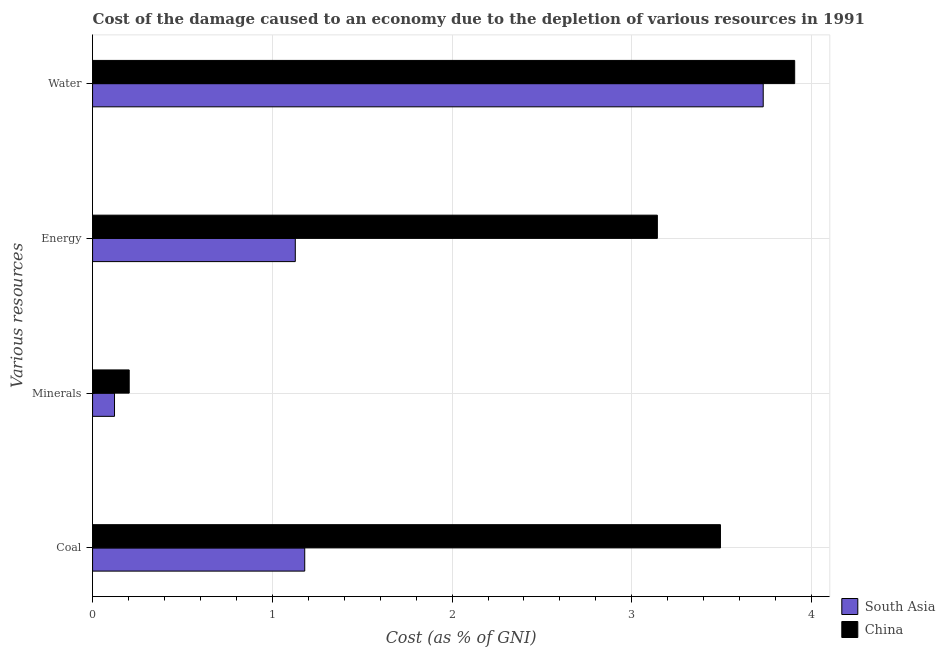How many groups of bars are there?
Ensure brevity in your answer.  4. How many bars are there on the 1st tick from the top?
Offer a very short reply. 2. How many bars are there on the 2nd tick from the bottom?
Your answer should be compact. 2. What is the label of the 2nd group of bars from the top?
Ensure brevity in your answer.  Energy. What is the cost of damage due to depletion of minerals in South Asia?
Your answer should be compact. 0.12. Across all countries, what is the maximum cost of damage due to depletion of minerals?
Give a very brief answer. 0.2. Across all countries, what is the minimum cost of damage due to depletion of water?
Your answer should be compact. 3.73. In which country was the cost of damage due to depletion of energy minimum?
Your response must be concise. South Asia. What is the total cost of damage due to depletion of coal in the graph?
Your answer should be compact. 4.67. What is the difference between the cost of damage due to depletion of coal in China and that in South Asia?
Offer a terse response. 2.31. What is the difference between the cost of damage due to depletion of energy in China and the cost of damage due to depletion of minerals in South Asia?
Make the answer very short. 3.02. What is the average cost of damage due to depletion of coal per country?
Offer a very short reply. 2.34. What is the difference between the cost of damage due to depletion of coal and cost of damage due to depletion of energy in South Asia?
Give a very brief answer. 0.05. What is the ratio of the cost of damage due to depletion of water in South Asia to that in China?
Provide a succinct answer. 0.96. Is the difference between the cost of damage due to depletion of water in South Asia and China greater than the difference between the cost of damage due to depletion of energy in South Asia and China?
Give a very brief answer. Yes. What is the difference between the highest and the second highest cost of damage due to depletion of energy?
Your answer should be very brief. 2.01. What is the difference between the highest and the lowest cost of damage due to depletion of energy?
Keep it short and to the point. 2.01. Is the sum of the cost of damage due to depletion of minerals in South Asia and China greater than the maximum cost of damage due to depletion of energy across all countries?
Your response must be concise. No. What does the 1st bar from the bottom in Coal represents?
Provide a succinct answer. South Asia. Is it the case that in every country, the sum of the cost of damage due to depletion of coal and cost of damage due to depletion of minerals is greater than the cost of damage due to depletion of energy?
Your answer should be very brief. Yes. Are all the bars in the graph horizontal?
Your response must be concise. Yes. What is the difference between two consecutive major ticks on the X-axis?
Provide a short and direct response. 1. Does the graph contain grids?
Your response must be concise. Yes. Where does the legend appear in the graph?
Offer a terse response. Bottom right. What is the title of the graph?
Keep it short and to the point. Cost of the damage caused to an economy due to the depletion of various resources in 1991 . What is the label or title of the X-axis?
Offer a very short reply. Cost (as % of GNI). What is the label or title of the Y-axis?
Your response must be concise. Various resources. What is the Cost (as % of GNI) in South Asia in Coal?
Keep it short and to the point. 1.18. What is the Cost (as % of GNI) in China in Coal?
Give a very brief answer. 3.49. What is the Cost (as % of GNI) in South Asia in Minerals?
Provide a succinct answer. 0.12. What is the Cost (as % of GNI) in China in Minerals?
Provide a succinct answer. 0.2. What is the Cost (as % of GNI) in South Asia in Energy?
Ensure brevity in your answer.  1.13. What is the Cost (as % of GNI) of China in Energy?
Offer a terse response. 3.14. What is the Cost (as % of GNI) of South Asia in Water?
Keep it short and to the point. 3.73. What is the Cost (as % of GNI) of China in Water?
Your answer should be compact. 3.91. Across all Various resources, what is the maximum Cost (as % of GNI) in South Asia?
Offer a very short reply. 3.73. Across all Various resources, what is the maximum Cost (as % of GNI) of China?
Offer a terse response. 3.91. Across all Various resources, what is the minimum Cost (as % of GNI) in South Asia?
Offer a very short reply. 0.12. Across all Various resources, what is the minimum Cost (as % of GNI) of China?
Keep it short and to the point. 0.2. What is the total Cost (as % of GNI) in South Asia in the graph?
Make the answer very short. 6.16. What is the total Cost (as % of GNI) of China in the graph?
Keep it short and to the point. 10.74. What is the difference between the Cost (as % of GNI) of South Asia in Coal and that in Minerals?
Offer a terse response. 1.06. What is the difference between the Cost (as % of GNI) in China in Coal and that in Minerals?
Make the answer very short. 3.29. What is the difference between the Cost (as % of GNI) of South Asia in Coal and that in Energy?
Offer a very short reply. 0.05. What is the difference between the Cost (as % of GNI) of China in Coal and that in Energy?
Your answer should be very brief. 0.35. What is the difference between the Cost (as % of GNI) of South Asia in Coal and that in Water?
Your answer should be compact. -2.55. What is the difference between the Cost (as % of GNI) of China in Coal and that in Water?
Make the answer very short. -0.41. What is the difference between the Cost (as % of GNI) in South Asia in Minerals and that in Energy?
Your response must be concise. -1.01. What is the difference between the Cost (as % of GNI) of China in Minerals and that in Energy?
Your answer should be very brief. -2.94. What is the difference between the Cost (as % of GNI) of South Asia in Minerals and that in Water?
Ensure brevity in your answer.  -3.61. What is the difference between the Cost (as % of GNI) in China in Minerals and that in Water?
Provide a succinct answer. -3.7. What is the difference between the Cost (as % of GNI) of South Asia in Energy and that in Water?
Your response must be concise. -2.6. What is the difference between the Cost (as % of GNI) of China in Energy and that in Water?
Make the answer very short. -0.76. What is the difference between the Cost (as % of GNI) of South Asia in Coal and the Cost (as % of GNI) of China in Minerals?
Your answer should be very brief. 0.98. What is the difference between the Cost (as % of GNI) in South Asia in Coal and the Cost (as % of GNI) in China in Energy?
Give a very brief answer. -1.96. What is the difference between the Cost (as % of GNI) in South Asia in Coal and the Cost (as % of GNI) in China in Water?
Keep it short and to the point. -2.73. What is the difference between the Cost (as % of GNI) in South Asia in Minerals and the Cost (as % of GNI) in China in Energy?
Provide a succinct answer. -3.02. What is the difference between the Cost (as % of GNI) of South Asia in Minerals and the Cost (as % of GNI) of China in Water?
Your response must be concise. -3.78. What is the difference between the Cost (as % of GNI) of South Asia in Energy and the Cost (as % of GNI) of China in Water?
Give a very brief answer. -2.78. What is the average Cost (as % of GNI) of South Asia per Various resources?
Provide a short and direct response. 1.54. What is the average Cost (as % of GNI) in China per Various resources?
Your answer should be very brief. 2.69. What is the difference between the Cost (as % of GNI) of South Asia and Cost (as % of GNI) of China in Coal?
Provide a short and direct response. -2.31. What is the difference between the Cost (as % of GNI) of South Asia and Cost (as % of GNI) of China in Minerals?
Keep it short and to the point. -0.08. What is the difference between the Cost (as % of GNI) in South Asia and Cost (as % of GNI) in China in Energy?
Offer a terse response. -2.01. What is the difference between the Cost (as % of GNI) of South Asia and Cost (as % of GNI) of China in Water?
Your answer should be compact. -0.18. What is the ratio of the Cost (as % of GNI) in South Asia in Coal to that in Minerals?
Give a very brief answer. 9.67. What is the ratio of the Cost (as % of GNI) of China in Coal to that in Minerals?
Provide a short and direct response. 17.14. What is the ratio of the Cost (as % of GNI) in South Asia in Coal to that in Energy?
Provide a succinct answer. 1.05. What is the ratio of the Cost (as % of GNI) in China in Coal to that in Energy?
Give a very brief answer. 1.11. What is the ratio of the Cost (as % of GNI) of South Asia in Coal to that in Water?
Make the answer very short. 0.32. What is the ratio of the Cost (as % of GNI) in China in Coal to that in Water?
Give a very brief answer. 0.89. What is the ratio of the Cost (as % of GNI) of South Asia in Minerals to that in Energy?
Offer a terse response. 0.11. What is the ratio of the Cost (as % of GNI) in China in Minerals to that in Energy?
Your answer should be very brief. 0.06. What is the ratio of the Cost (as % of GNI) of South Asia in Minerals to that in Water?
Make the answer very short. 0.03. What is the ratio of the Cost (as % of GNI) of China in Minerals to that in Water?
Keep it short and to the point. 0.05. What is the ratio of the Cost (as % of GNI) of South Asia in Energy to that in Water?
Keep it short and to the point. 0.3. What is the ratio of the Cost (as % of GNI) in China in Energy to that in Water?
Make the answer very short. 0.8. What is the difference between the highest and the second highest Cost (as % of GNI) in South Asia?
Provide a succinct answer. 2.55. What is the difference between the highest and the second highest Cost (as % of GNI) in China?
Give a very brief answer. 0.41. What is the difference between the highest and the lowest Cost (as % of GNI) in South Asia?
Offer a very short reply. 3.61. What is the difference between the highest and the lowest Cost (as % of GNI) in China?
Your response must be concise. 3.7. 